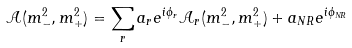Convert formula to latex. <formula><loc_0><loc_0><loc_500><loc_500>\mathcal { A } ( m _ { - } ^ { 2 } , m _ { + } ^ { 2 } ) = \sum _ { r } a _ { r } e ^ { i \phi _ { r } } \mathcal { A } _ { r } ( m _ { - } ^ { 2 } , m _ { + } ^ { 2 } ) + a _ { N R } e ^ { i \phi _ { N R } }</formula> 